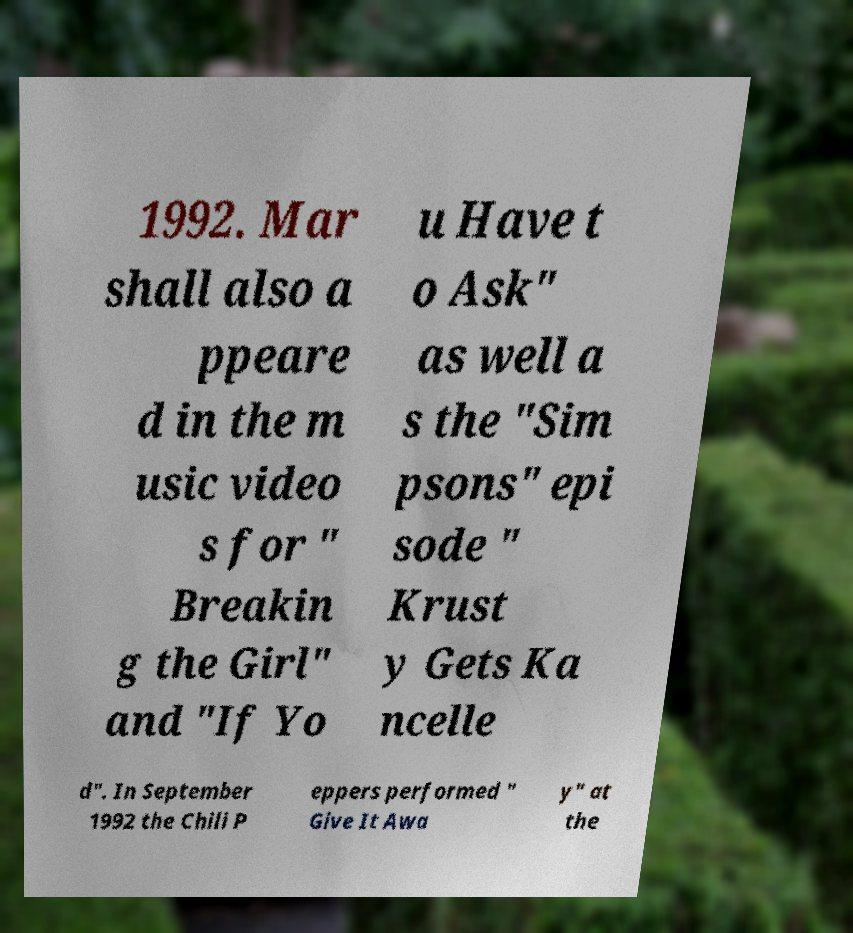What messages or text are displayed in this image? I need them in a readable, typed format. 1992. Mar shall also a ppeare d in the m usic video s for " Breakin g the Girl" and "If Yo u Have t o Ask" as well a s the "Sim psons" epi sode " Krust y Gets Ka ncelle d". In September 1992 the Chili P eppers performed " Give It Awa y" at the 